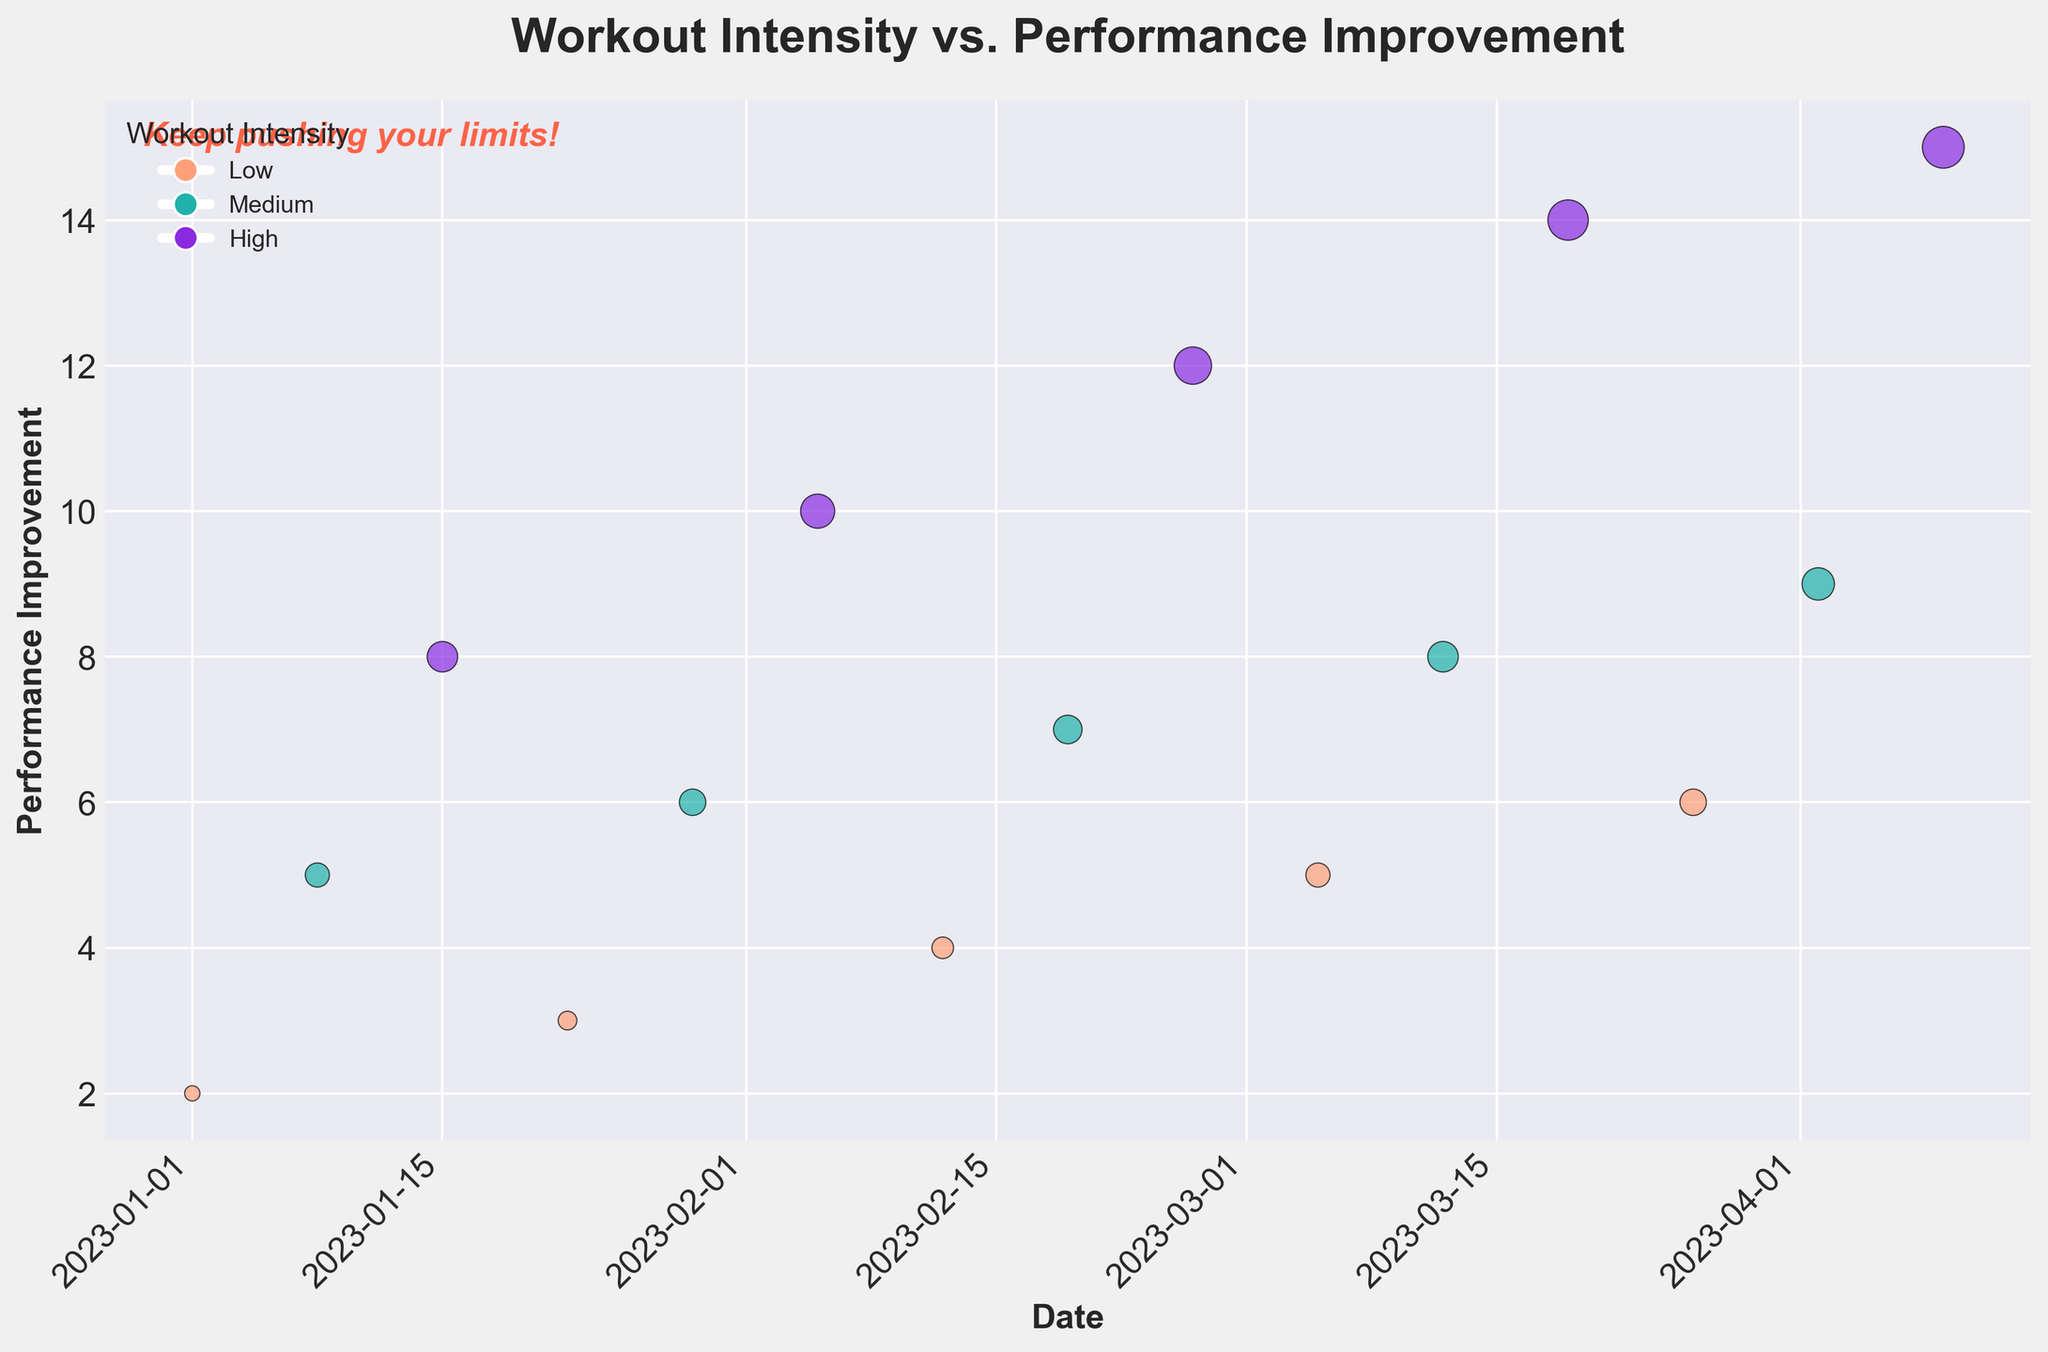How many different workout intensity levels are represented in the scatter plot? The legend shows three markers each representing a different workout intensity level: Low, Medium, and High.
Answer: 3 What is the color representation for 'High' workout intensity in the scatter plot? The legend indicates that 'High' workout intensity is represented by a purple marker.
Answer: Purple What is the highest recorded performance improvement and on what date did it occur? The scatter plot shows that the highest performance improvement is 15, which occurred on 2023-04-09 based on the data points and x-axis labels.
Answer: 15 on 2023-04-09 How does performance improvement generally vary with workout intensity level? Observing the data points' colors and their positions, higher workout intensity appears to be correlated with higher performance improvement values.
Answer: High intensity shows higher improvement What is the performance improvement for 'Medium' workout intensity on 2023-03-12? The scatter plot shows a teal marker (indicating 'Medium' intensity) at a performance improvement level of 8 on 2023-03-12.
Answer: 8 On which date was there a performance improvement of 10, and what was the workout intensity level on that date? A purple marker indicating 'High' intensity is at the performance improvement level of 10, on the date 2023-02-05.
Answer: 2023-02-05, High How many total data points were plotted in the scatter plot? Plotting each point separately shows the cumulative total data points for each 'Low', 'Medium', and 'High' intensity, leading to a count of 15.
Answer: 15 Which workout intensity level shows the most significant range of performance improvement values? By observing the spread of data points and sizes for each intensity color: 'High' intensity shows the largest spread from 8 to 15.
Answer: High 